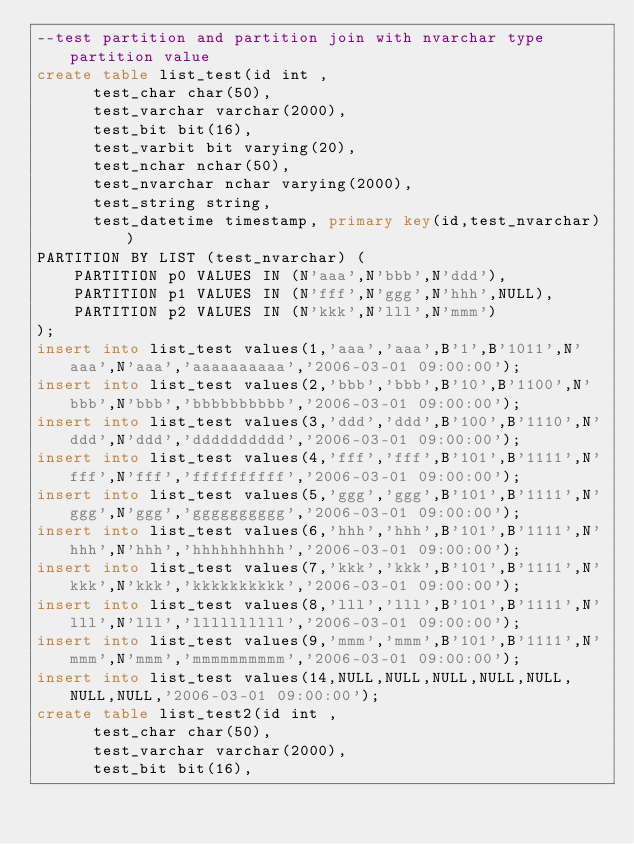<code> <loc_0><loc_0><loc_500><loc_500><_SQL_>--test partition and partition join with nvarchar type partition value
create table list_test(id int ,       
			test_char char(50),                
			test_varchar varchar(2000),        
			test_bit bit(16),                  
			test_varbit bit varying(20),       
			test_nchar nchar(50),              
			test_nvarchar nchar varying(2000), 
			test_string string,                
			test_datetime timestamp, primary key(id,test_nvarchar))           
PARTITION BY LIST (test_nvarchar) (                            
    PARTITION p0 VALUES IN (N'aaa',N'bbb',N'ddd'),            
    PARTITION p1 VALUES IN (N'fff',N'ggg',N'hhh',NULL),       
    PARTITION p2 VALUES IN (N'kkk',N'lll',N'mmm')             
);             
insert into list_test values(1,'aaa','aaa',B'1',B'1011',N'aaa',N'aaa','aaaaaaaaaa','2006-03-01 09:00:00');  
insert into list_test values(2,'bbb','bbb',B'10',B'1100',N'bbb',N'bbb','bbbbbbbbbb','2006-03-01 09:00:00'); 
insert into list_test values(3,'ddd','ddd',B'100',B'1110',N'ddd',N'ddd','dddddddddd','2006-03-01 09:00:00');
insert into list_test values(4,'fff','fff',B'101',B'1111',N'fff',N'fff','ffffffffff','2006-03-01 09:00:00');
insert into list_test values(5,'ggg','ggg',B'101',B'1111',N'ggg',N'ggg','gggggggggg','2006-03-01 09:00:00');
insert into list_test values(6,'hhh','hhh',B'101',B'1111',N'hhh',N'hhh','hhhhhhhhhh','2006-03-01 09:00:00');
insert into list_test values(7,'kkk','kkk',B'101',B'1111',N'kkk',N'kkk','kkkkkkkkkk','2006-03-01 09:00:00');
insert into list_test values(8,'lll','lll',B'101',B'1111',N'lll',N'lll','llllllllll','2006-03-01 09:00:00');
insert into list_test values(9,'mmm','mmm',B'101',B'1111',N'mmm',N'mmm','mmmmmmmmmm','2006-03-01 09:00:00');
insert into list_test values(14,NULL,NULL,NULL,NULL,NULL,NULL,NULL,'2006-03-01 09:00:00');
create table list_test2(id int ,       
			test_char char(50),                
			test_varchar varchar(2000),        
			test_bit bit(16),                  </code> 